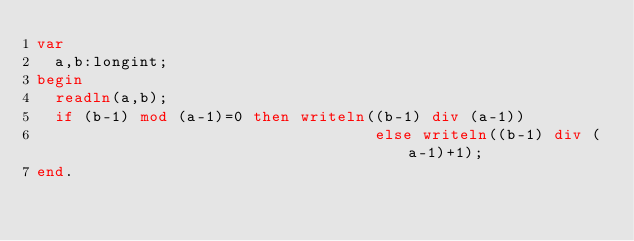<code> <loc_0><loc_0><loc_500><loc_500><_Pascal_>var
  a,b:longint;
begin
  readln(a,b);
  if (b-1) mod (a-1)=0 then writeln((b-1) div (a-1))
                                    else writeln((b-1) div (a-1)+1);
end.</code> 